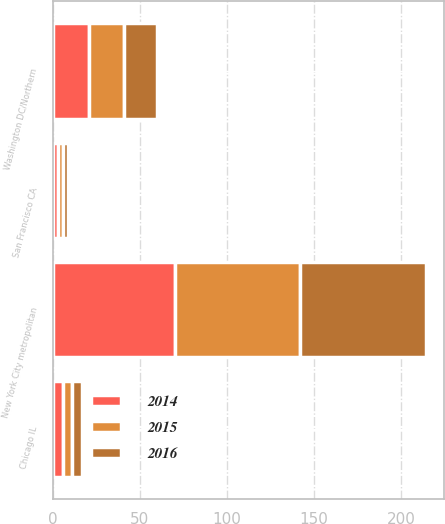<chart> <loc_0><loc_0><loc_500><loc_500><stacked_bar_chart><ecel><fcel>New York City metropolitan<fcel>Washington DC/Northern<fcel>Chicago IL<fcel>San Francisco CA<nl><fcel>2016<fcel>72<fcel>19<fcel>6<fcel>3<nl><fcel>2015<fcel>72<fcel>20<fcel>5<fcel>3<nl><fcel>2014<fcel>70<fcel>21<fcel>6<fcel>3<nl></chart> 